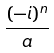<formula> <loc_0><loc_0><loc_500><loc_500>\frac { ( - i ) ^ { n } } { a }</formula> 